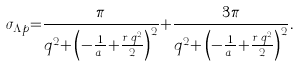Convert formula to latex. <formula><loc_0><loc_0><loc_500><loc_500>\sigma _ { \Lambda { p } } { = } \frac { \pi } { q ^ { 2 } { + } \left ( - \frac { 1 } { a _ { s } } { + } \frac { r _ { s } q ^ { 2 } } { 2 } \right ) ^ { 2 } } { + } \frac { 3 \pi } { q ^ { 2 } { + } \left ( - \frac { 1 } { a _ { t } } { + } \frac { r _ { t } q ^ { 2 } } { 2 } \right ) ^ { 2 } } .</formula> 